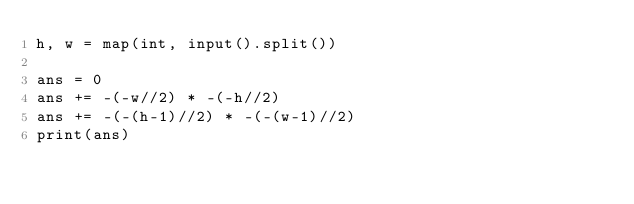Convert code to text. <code><loc_0><loc_0><loc_500><loc_500><_Python_>h, w = map(int, input().split())

ans = 0
ans += -(-w//2) * -(-h//2)
ans += -(-(h-1)//2) * -(-(w-1)//2)
print(ans)</code> 